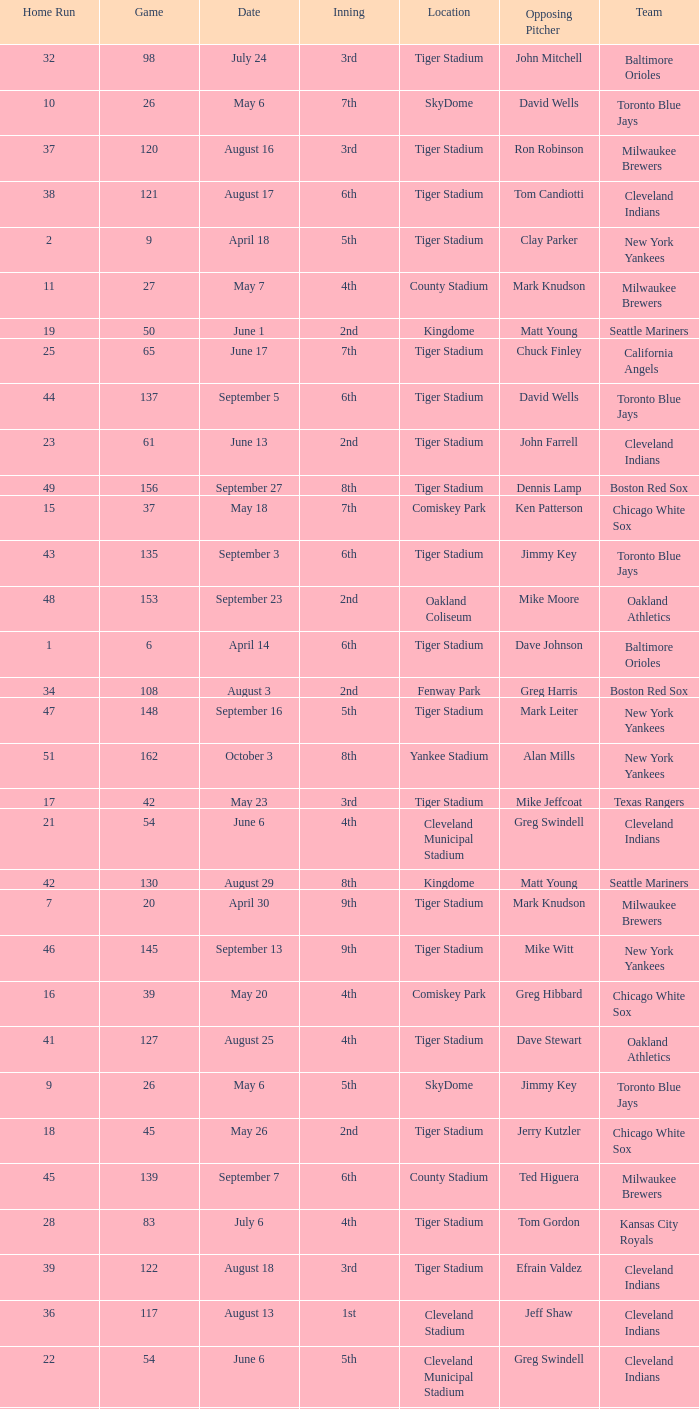When Efrain Valdez was pitching, what was the highest home run? 39.0. 